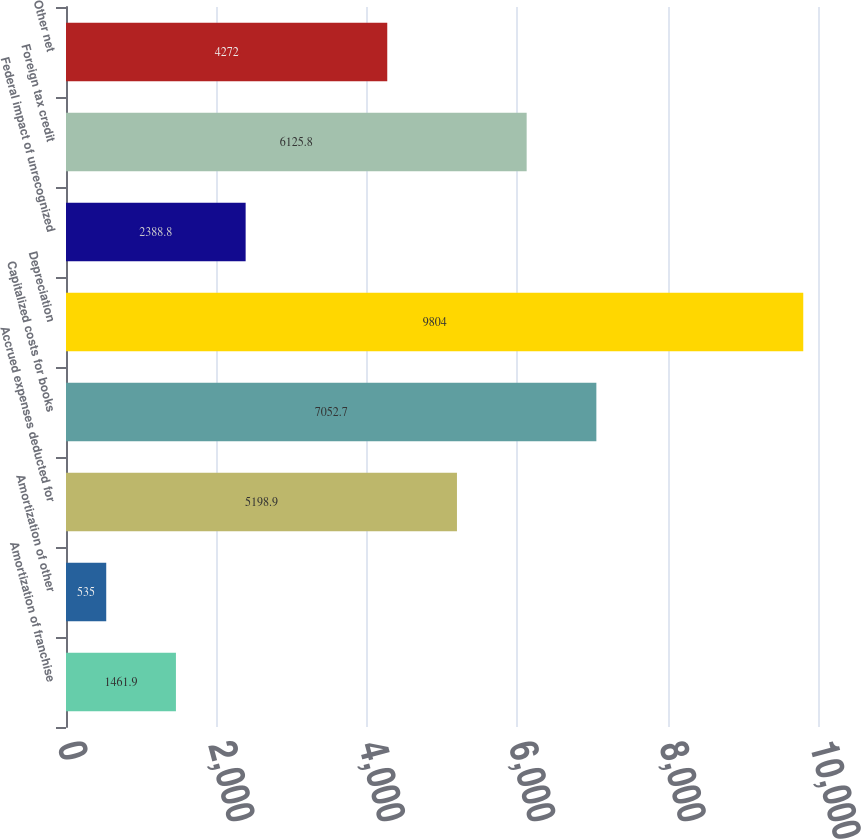Convert chart to OTSL. <chart><loc_0><loc_0><loc_500><loc_500><bar_chart><fcel>Amortization of franchise<fcel>Amortization of other<fcel>Accrued expenses deducted for<fcel>Capitalized costs for books<fcel>Depreciation<fcel>Federal impact of unrecognized<fcel>Foreign tax credit<fcel>Other net<nl><fcel>1461.9<fcel>535<fcel>5198.9<fcel>7052.7<fcel>9804<fcel>2388.8<fcel>6125.8<fcel>4272<nl></chart> 